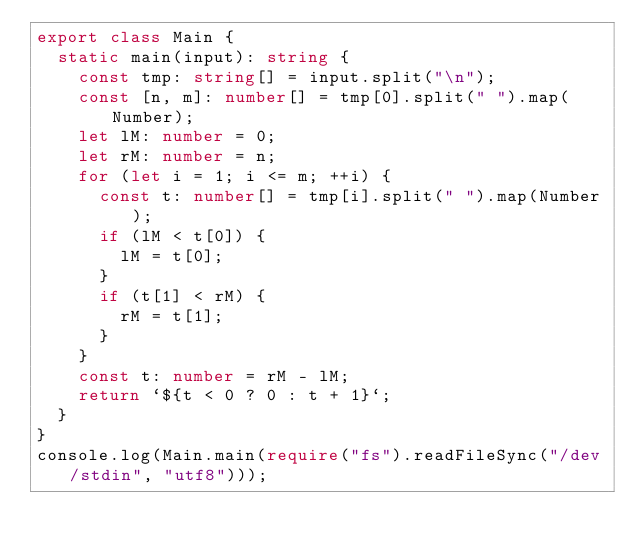<code> <loc_0><loc_0><loc_500><loc_500><_TypeScript_>export class Main {
  static main(input): string {
    const tmp: string[] = input.split("\n");
    const [n, m]: number[] = tmp[0].split(" ").map(Number);
    let lM: number = 0;
    let rM: number = n;
    for (let i = 1; i <= m; ++i) {
      const t: number[] = tmp[i].split(" ").map(Number);
      if (lM < t[0]) {
        lM = t[0];
      }
      if (t[1] < rM) {
        rM = t[1];
      }
    }
    const t: number = rM - lM;
    return `${t < 0 ? 0 : t + 1}`;
  }
}
console.log(Main.main(require("fs").readFileSync("/dev/stdin", "utf8")));</code> 